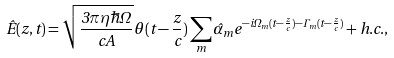<formula> <loc_0><loc_0><loc_500><loc_500>\hat { E } ( z , t ) = \sqrt { \frac { 3 \pi \eta \hbar { \Omega } } { c A } } { \theta } ( t - \frac { z } { c } ) \sum _ { m } \hat { \alpha } _ { m } e ^ { - i \Omega _ { m } ( t - \frac { z } { c } ) - \Gamma _ { m } ( t - \frac { z } { c } ) } + h . c . ,</formula> 